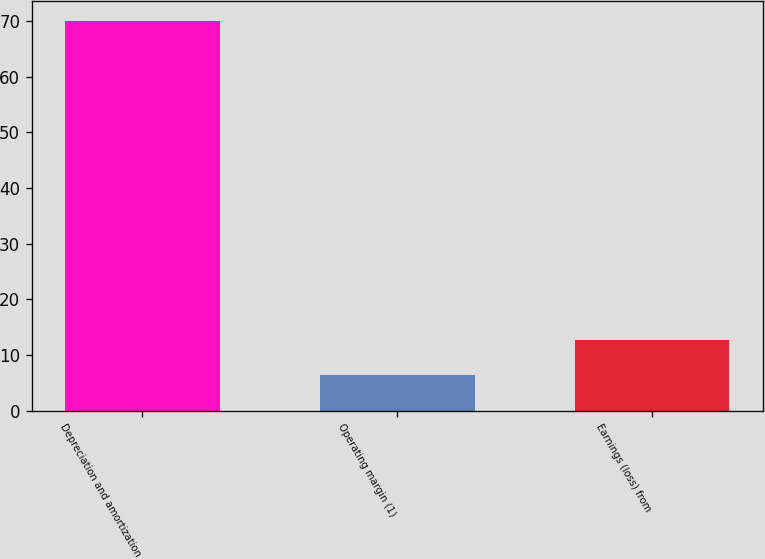Convert chart to OTSL. <chart><loc_0><loc_0><loc_500><loc_500><bar_chart><fcel>Depreciation and amortization<fcel>Operating margin (1)<fcel>Earnings (loss) from<nl><fcel>70<fcel>6.3<fcel>12.67<nl></chart> 